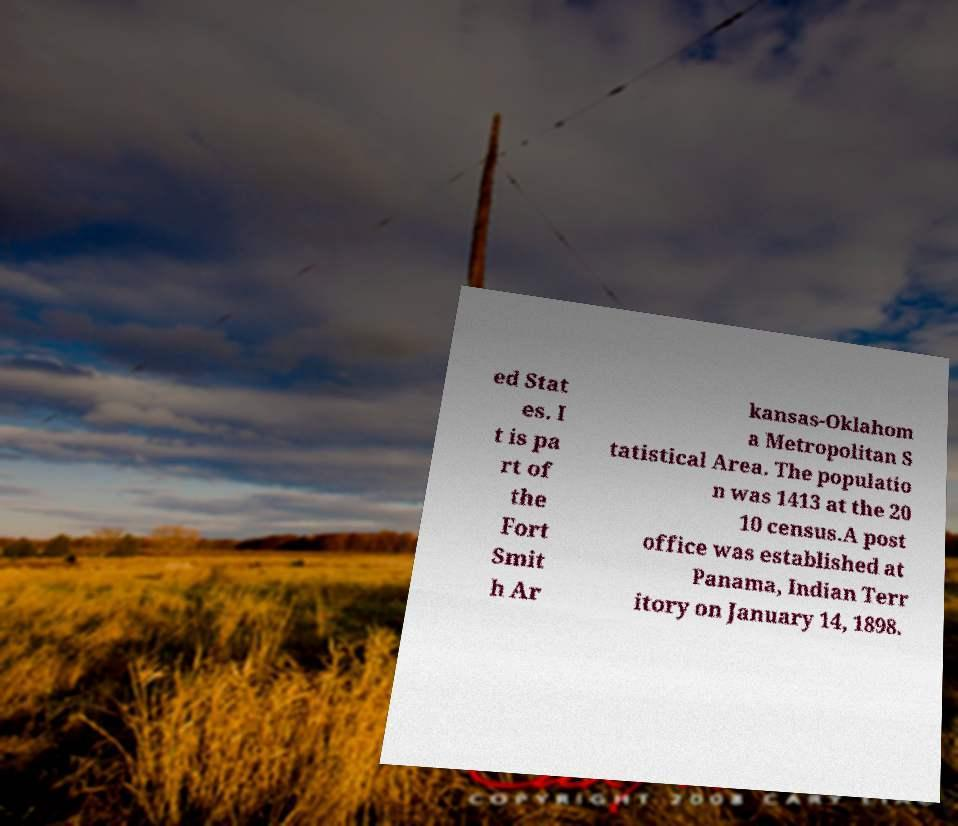Could you assist in decoding the text presented in this image and type it out clearly? ed Stat es. I t is pa rt of the Fort Smit h Ar kansas-Oklahom a Metropolitan S tatistical Area. The populatio n was 1413 at the 20 10 census.A post office was established at Panama, Indian Terr itory on January 14, 1898. 